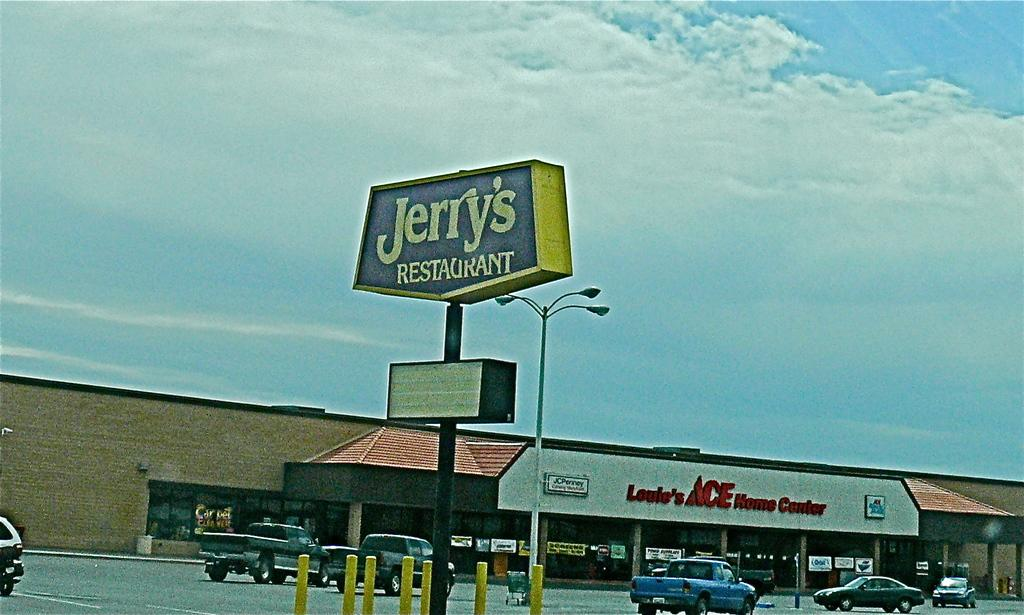<image>
Relay a brief, clear account of the picture shown. Sitting in a parking lot of Jerry restaurant with Ace home center in the background. 